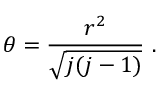<formula> <loc_0><loc_0><loc_500><loc_500>\theta = \frac { r ^ { 2 } } { \sqrt { j ( j - 1 ) } } .</formula> 